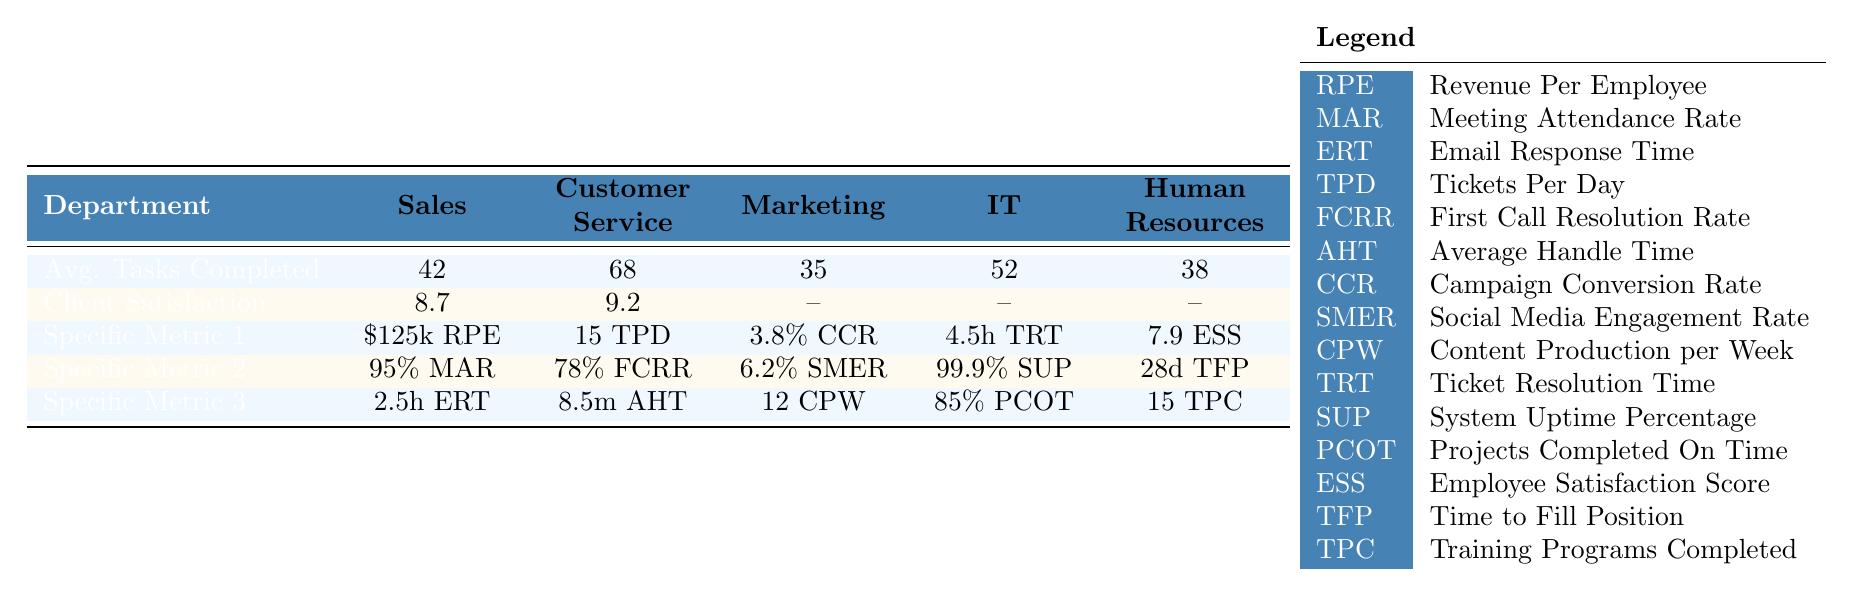What is the average number of tasks completed in the Sales department? The table directly shows that the average tasks completed in the Sales department is 42.
Answer: 42 Which department has the highest client satisfaction score? The table indicates that the Customer Service department has the highest client satisfaction score at 9.2.
Answer: Customer Service What is the revenue per employee in the IT department? According to the table, the revenue per employee in the IT department is \$125k.
Answer: \$125k How many training programs were completed in the Human Resources department? The table reveals that the Human Resources department completed 15 training programs.
Answer: 15 What is the difference between the average tasks completed in Customer Service and Marketing? Customer Service completed 68 tasks while Marketing completed 35 tasks. The difference is calculated as 68 - 35 = 33.
Answer: 33 What is the average handle time in the Customer Service department? The table specifies that the average handle time in the Customer Service department is 8.5 minutes.
Answer: 8.5 minutes Are there any specific metrics mentioned for the Marketing department? The table shows specific metrics for the Marketing department, including a campaign conversion rate of 3.8% and a social media engagement rate of 6.2%.
Answer: Yes Which department has the highest average tasks completed? The Customer Service department has the highest average tasks completed at 68, compared to other departments.
Answer: Customer Service If the average handle time in the Customer Service department were reduced by 1 minute, what would the new average handle time be? The current average handle time is 8.5 minutes. Reducing this by 1 minute gives us 8.5 - 1 = 7.5 minutes.
Answer: 7.5 minutes What percentage of projects are completed on time in the IT department? The table indicates that 85% of projects are completed on time in the IT department.
Answer: 85% 